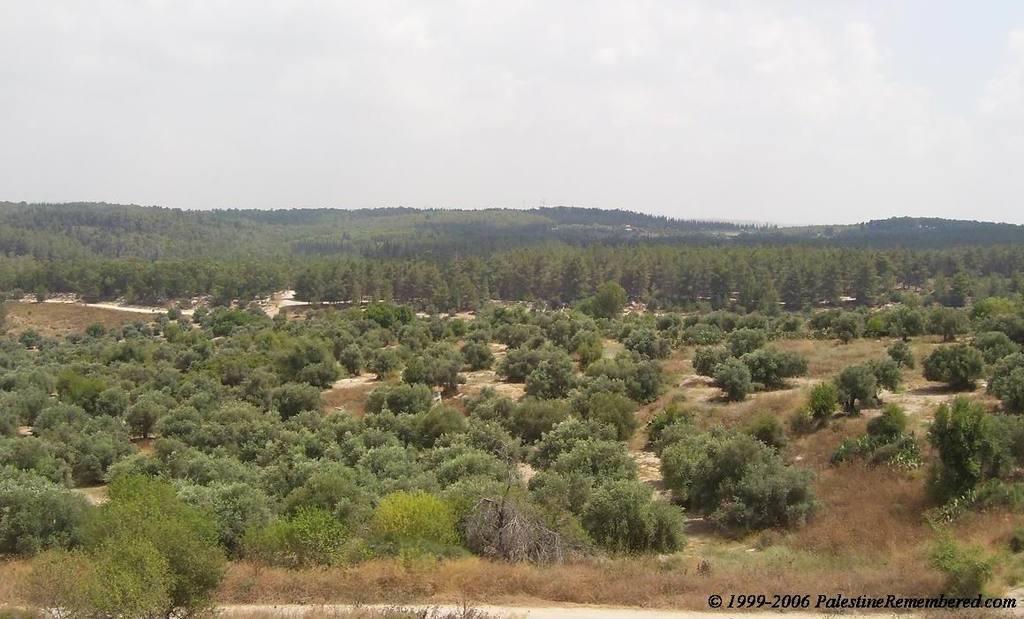How would you summarize this image in a sentence or two? In this picture we can see there are trees, hills and the sky. On the image there is a watermark. 